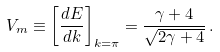<formula> <loc_0><loc_0><loc_500><loc_500>V _ { m } \equiv \left [ { \frac { d E } { d k } } \right ] _ { k = \pi } = { \frac { \gamma + 4 } { \sqrt { 2 \gamma + 4 } } } \, .</formula> 